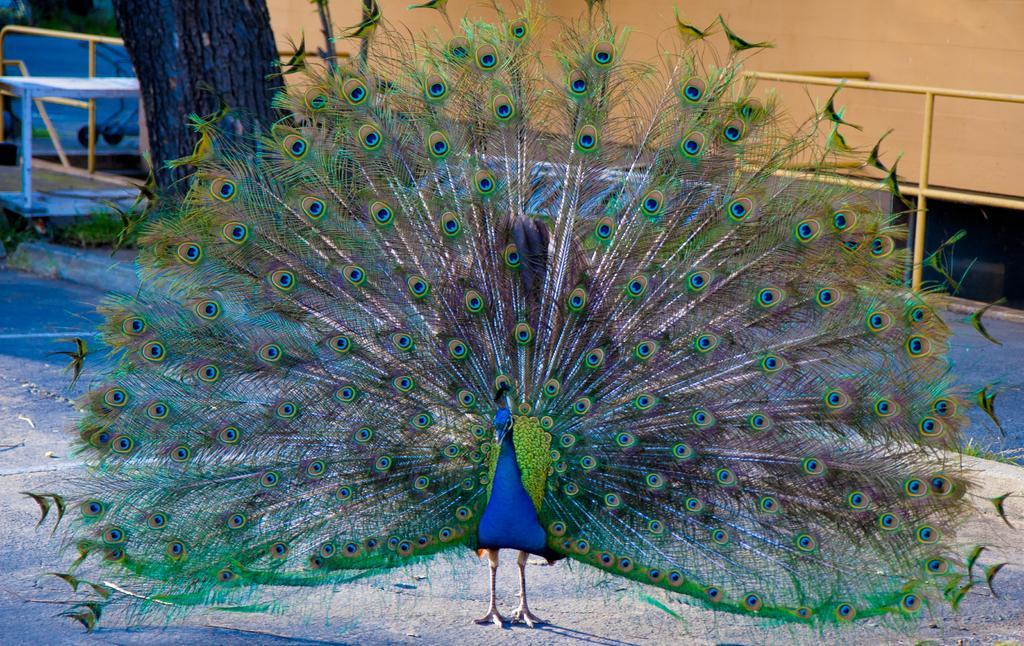Describe this image in one or two sentences. In this picture I can see a peacock on the ground and I can see a tree and looks like a cloth in the back. 